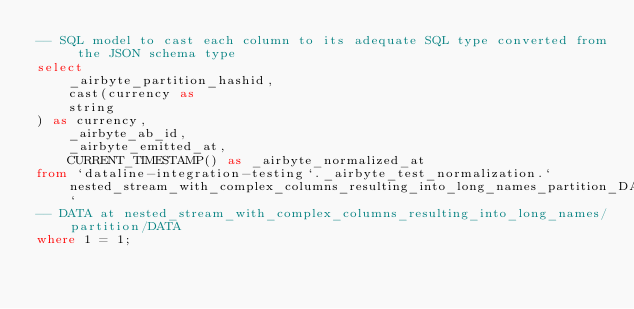Convert code to text. <code><loc_0><loc_0><loc_500><loc_500><_SQL_>-- SQL model to cast each column to its adequate SQL type converted from the JSON schema type
select
    _airbyte_partition_hashid,
    cast(currency as 
    string
) as currency,
    _airbyte_ab_id,
    _airbyte_emitted_at,
    CURRENT_TIMESTAMP() as _airbyte_normalized_at
from `dataline-integration-testing`._airbyte_test_normalization.`nested_stream_with_complex_columns_resulting_into_long_names_partition_DATA_ab1`
-- DATA at nested_stream_with_complex_columns_resulting_into_long_names/partition/DATA
where 1 = 1;

</code> 